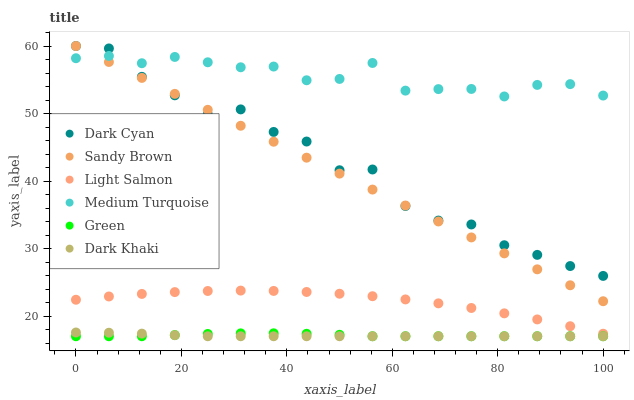Does Dark Khaki have the minimum area under the curve?
Answer yes or no. Yes. Does Medium Turquoise have the maximum area under the curve?
Answer yes or no. Yes. Does Green have the minimum area under the curve?
Answer yes or no. No. Does Green have the maximum area under the curve?
Answer yes or no. No. Is Sandy Brown the smoothest?
Answer yes or no. Yes. Is Dark Cyan the roughest?
Answer yes or no. Yes. Is Dark Khaki the smoothest?
Answer yes or no. No. Is Dark Khaki the roughest?
Answer yes or no. No. Does Dark Khaki have the lowest value?
Answer yes or no. Yes. Does Medium Turquoise have the lowest value?
Answer yes or no. No. Does Sandy Brown have the highest value?
Answer yes or no. Yes. Does Dark Khaki have the highest value?
Answer yes or no. No. Is Light Salmon less than Dark Cyan?
Answer yes or no. Yes. Is Light Salmon greater than Dark Khaki?
Answer yes or no. Yes. Does Green intersect Dark Khaki?
Answer yes or no. Yes. Is Green less than Dark Khaki?
Answer yes or no. No. Is Green greater than Dark Khaki?
Answer yes or no. No. Does Light Salmon intersect Dark Cyan?
Answer yes or no. No. 